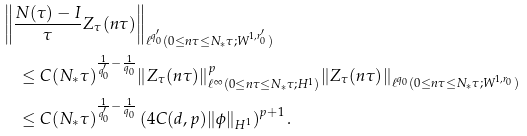Convert formula to latex. <formula><loc_0><loc_0><loc_500><loc_500>& \left \| \frac { N ( \tau ) - I } { \tau } Z _ { \tau } ( n \tau ) \right \| _ { \ell ^ { q _ { 0 } ^ { \prime } } ( 0 \leq n \tau \leq N _ { * } \tau ; W ^ { 1 , r _ { 0 } ^ { \prime } } ) } \\ & \quad \leq C ( N _ { * } \tau ) ^ { \frac { 1 } { q _ { 0 } ^ { \prime } } - \frac { 1 } { q _ { 0 } } } \| Z _ { \tau } ( n \tau ) \| _ { \ell ^ { \infty } ( 0 \leq n \tau \leq N _ { * } \tau ; H ^ { 1 } ) } ^ { p } \| Z _ { \tau } ( n \tau ) \| _ { \ell ^ { q _ { 0 } } ( 0 \leq n \tau \leq N _ { * } \tau ; W ^ { 1 , r _ { 0 } } ) } \\ & \quad \leq C ( N _ { * } \tau ) ^ { \frac { 1 } { q _ { 0 } ^ { \prime } } - \frac { 1 } { q _ { 0 } } } \left ( 4 C ( d , p ) \| \phi \| _ { { H } ^ { 1 } } \right ) ^ { p + 1 } .</formula> 